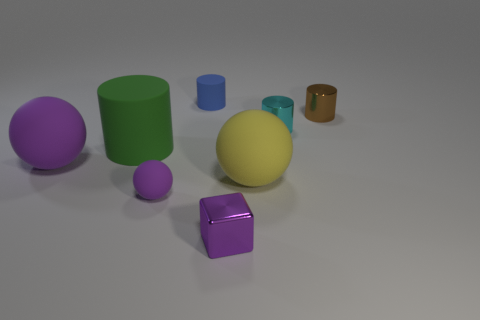Add 1 green shiny spheres. How many objects exist? 9 Subtract all blocks. How many objects are left? 7 Add 8 big cyan metallic cylinders. How many big cyan metallic cylinders exist? 8 Subtract 0 green spheres. How many objects are left? 8 Subtract all brown spheres. Subtract all purple rubber spheres. How many objects are left? 6 Add 3 large rubber cylinders. How many large rubber cylinders are left? 4 